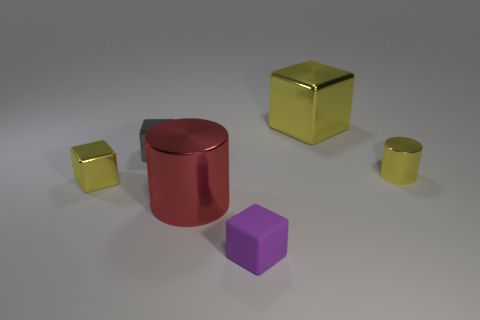Is there anything else that is the same color as the matte thing?
Make the answer very short. No. Are there an equal number of tiny purple blocks on the right side of the tiny yellow metal cylinder and yellow objects that are on the left side of the big yellow metal thing?
Provide a short and direct response. No. Are there more large metal blocks behind the small purple matte cube than large shiny cylinders?
Your response must be concise. No. How many things are either big red shiny cylinders left of the big yellow shiny block or tiny brown blocks?
Offer a very short reply. 1. What number of yellow blocks are made of the same material as the gray object?
Your answer should be compact. 2. There is a small metallic thing that is the same color as the tiny metallic cylinder; what is its shape?
Your answer should be compact. Cube. Is there a small yellow metal object that has the same shape as the tiny gray thing?
Offer a very short reply. Yes. Do the small rubber block and the shiny thing left of the small gray shiny thing have the same color?
Your answer should be very brief. No. There is a tiny object that is right of the small purple rubber thing; what number of tiny cubes are behind it?
Your response must be concise. 1. There is a cube that is to the right of the red cylinder and behind the red metallic thing; what size is it?
Ensure brevity in your answer.  Large. 